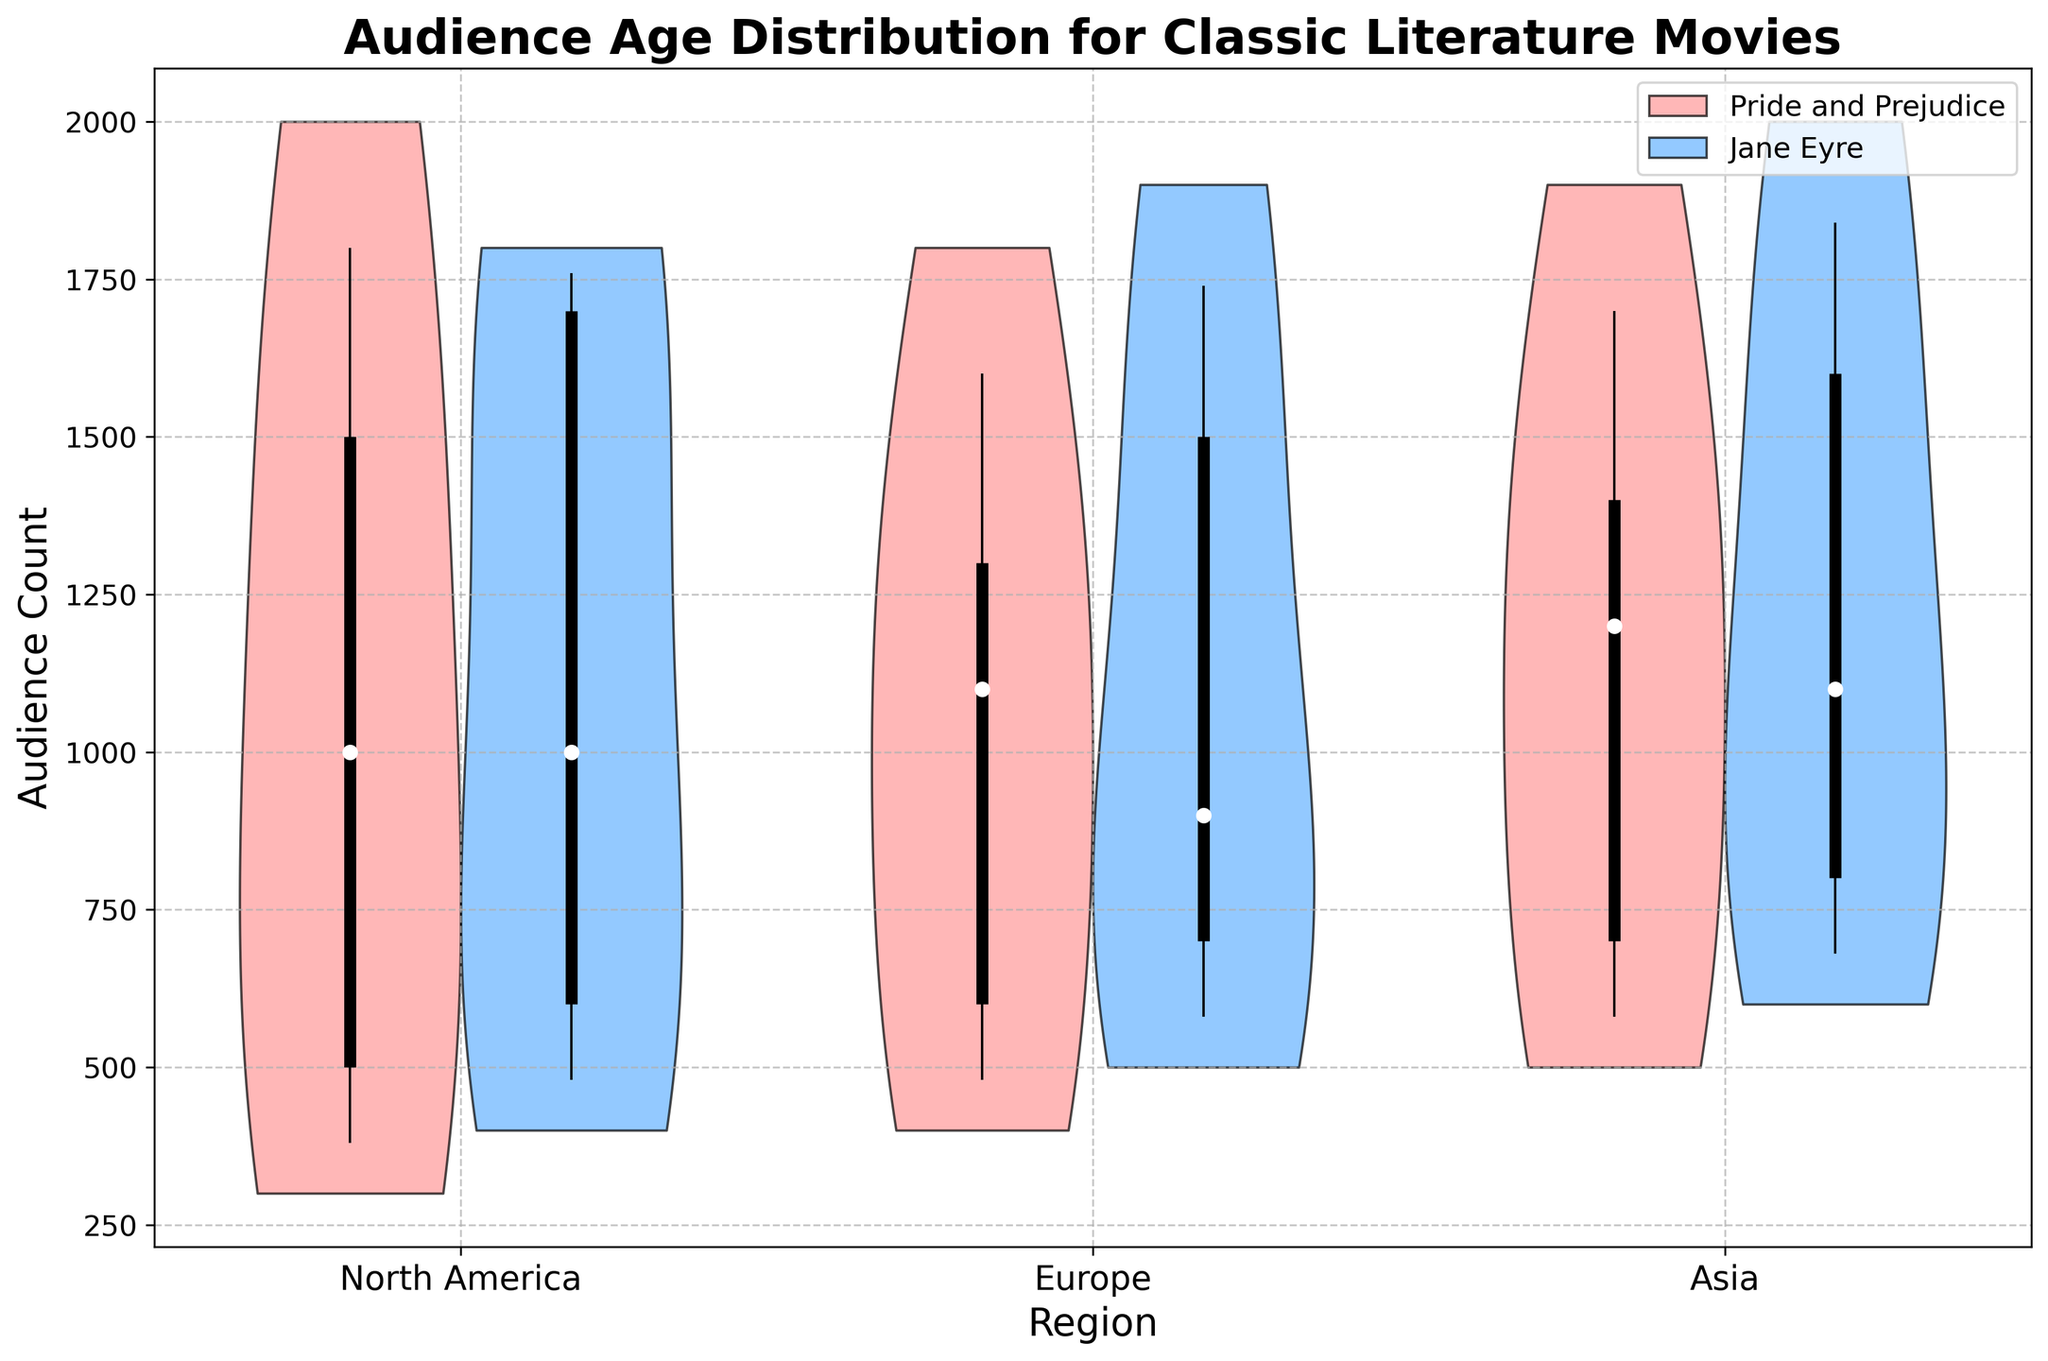What is the title of the chart? The title of the chart is usually placed at the top and describes what the chart is about. The title of this chart is "Audience Age Distribution for Classic Literature Movies".
Answer: Audience Age Distribution for Classic Literature Movies What is the audience count for the 18-24 age group in North America for the movie 'Jane Eyre'? Find the violin plot that represents 'Jane Eyre' in North America, then locate the plot for the 18-24 age group. The violin chart shows the distribution with the maximum point, which is the audience count for that age group.
Answer: 1700 Which region appears to have the highest median audience count for 'Pride and Prejudice'? Examine the median points (white dots) on the violin plots for 'Pride and Prejudice' across all regions. The region with the highest median point is the one with the highest median audience count.
Answer: Asia How does the audience count distribution for the 25-34 age group compare between North America and Europe for 'Jane Eyre'? Compare the violin plots for the 25-34 age group between North America and Europe for 'Jane Eyre'. Look at the shapes, spread, and median points (white dots) of the violins for both regions.
Answer: Similar, though Europe has a slightly higher count What age group has the smallest audience count range in Europe for 'Pride and Prejudice'? In the box plot overlays within the violin plots, identify which age group has the shortest whiskers range, representing the smallest audience count range in Europe for 'Pride and Prejudice'.
Answer: 55+ Which movie has a wider audience count distribution for the 45-54 age group in Asia? Compare the width of the violin plots for the 45-54 age group between the two movies in Asia. The movie with the wider violin plot has a wider distribution.
Answer: Jane Eyre What is the general trend in audience counts across age groups for 'Pride and Prejudice' in North America? Examine the violin plots for each age group for 'Pride and Prejudice' in North America. Observe if there is a rise or decline in audience counts as the age progresses.
Answer: Decreasing trend Is the audience count more consistent across age groups in Europe for 'Jane Eyre' or 'Pride and Prejudice'? Look at the spread and consistency of the violin plots across different age groups for each movie in Europe. The movie with less variation in the shapes and spreads of the violins has a more consistent audience count.
Answer: Jane Eyre Which movie has the highest overall audience count in Asia? Compare the sum of the audience counts across all age groups for each movie in Asia, observable from the violin plots. The movie with the higher cumulative height in its violins has the highest overall audience count.
Answer: Jane Eyre 